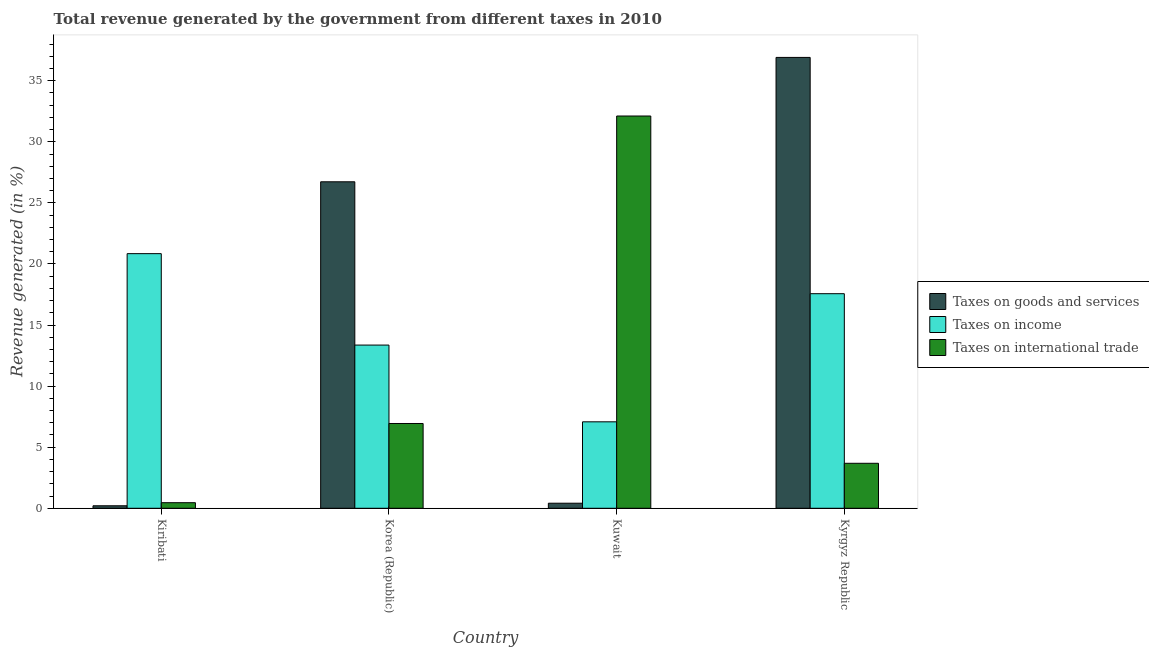Are the number of bars on each tick of the X-axis equal?
Keep it short and to the point. Yes. How many bars are there on the 3rd tick from the left?
Offer a terse response. 3. How many bars are there on the 1st tick from the right?
Make the answer very short. 3. What is the label of the 4th group of bars from the left?
Provide a succinct answer. Kyrgyz Republic. What is the percentage of revenue generated by taxes on goods and services in Korea (Republic)?
Keep it short and to the point. 26.73. Across all countries, what is the maximum percentage of revenue generated by taxes on income?
Give a very brief answer. 20.84. Across all countries, what is the minimum percentage of revenue generated by tax on international trade?
Keep it short and to the point. 0.46. In which country was the percentage of revenue generated by tax on international trade maximum?
Offer a very short reply. Kuwait. In which country was the percentage of revenue generated by taxes on income minimum?
Offer a terse response. Kuwait. What is the total percentage of revenue generated by taxes on income in the graph?
Make the answer very short. 58.85. What is the difference between the percentage of revenue generated by taxes on income in Kiribati and that in Kyrgyz Republic?
Offer a very short reply. 3.28. What is the difference between the percentage of revenue generated by tax on international trade in Kiribati and the percentage of revenue generated by taxes on goods and services in Korea (Republic)?
Provide a succinct answer. -26.27. What is the average percentage of revenue generated by taxes on goods and services per country?
Your response must be concise. 16.06. What is the difference between the percentage of revenue generated by tax on international trade and percentage of revenue generated by taxes on income in Kiribati?
Keep it short and to the point. -20.39. What is the ratio of the percentage of revenue generated by tax on international trade in Kiribati to that in Kuwait?
Your answer should be compact. 0.01. Is the percentage of revenue generated by taxes on income in Kiribati less than that in Kyrgyz Republic?
Offer a very short reply. No. Is the difference between the percentage of revenue generated by taxes on goods and services in Kiribati and Kyrgyz Republic greater than the difference between the percentage of revenue generated by taxes on income in Kiribati and Kyrgyz Republic?
Make the answer very short. No. What is the difference between the highest and the second highest percentage of revenue generated by taxes on income?
Give a very brief answer. 3.28. What is the difference between the highest and the lowest percentage of revenue generated by taxes on income?
Keep it short and to the point. 13.77. In how many countries, is the percentage of revenue generated by taxes on goods and services greater than the average percentage of revenue generated by taxes on goods and services taken over all countries?
Provide a short and direct response. 2. What does the 3rd bar from the left in Kyrgyz Republic represents?
Your response must be concise. Taxes on international trade. What does the 3rd bar from the right in Kiribati represents?
Your answer should be very brief. Taxes on goods and services. Does the graph contain grids?
Make the answer very short. No. Where does the legend appear in the graph?
Give a very brief answer. Center right. How many legend labels are there?
Offer a terse response. 3. How are the legend labels stacked?
Your response must be concise. Vertical. What is the title of the graph?
Provide a short and direct response. Total revenue generated by the government from different taxes in 2010. What is the label or title of the X-axis?
Your response must be concise. Country. What is the label or title of the Y-axis?
Offer a terse response. Revenue generated (in %). What is the Revenue generated (in %) in Taxes on goods and services in Kiribati?
Your answer should be compact. 0.2. What is the Revenue generated (in %) of Taxes on income in Kiribati?
Ensure brevity in your answer.  20.84. What is the Revenue generated (in %) in Taxes on international trade in Kiribati?
Provide a succinct answer. 0.46. What is the Revenue generated (in %) of Taxes on goods and services in Korea (Republic)?
Your response must be concise. 26.73. What is the Revenue generated (in %) in Taxes on income in Korea (Republic)?
Ensure brevity in your answer.  13.36. What is the Revenue generated (in %) in Taxes on international trade in Korea (Republic)?
Your answer should be compact. 6.94. What is the Revenue generated (in %) in Taxes on goods and services in Kuwait?
Ensure brevity in your answer.  0.41. What is the Revenue generated (in %) in Taxes on income in Kuwait?
Your answer should be very brief. 7.08. What is the Revenue generated (in %) of Taxes on international trade in Kuwait?
Your answer should be very brief. 32.11. What is the Revenue generated (in %) of Taxes on goods and services in Kyrgyz Republic?
Make the answer very short. 36.91. What is the Revenue generated (in %) of Taxes on income in Kyrgyz Republic?
Provide a short and direct response. 17.57. What is the Revenue generated (in %) in Taxes on international trade in Kyrgyz Republic?
Your response must be concise. 3.68. Across all countries, what is the maximum Revenue generated (in %) of Taxes on goods and services?
Offer a terse response. 36.91. Across all countries, what is the maximum Revenue generated (in %) of Taxes on income?
Your answer should be very brief. 20.84. Across all countries, what is the maximum Revenue generated (in %) of Taxes on international trade?
Make the answer very short. 32.11. Across all countries, what is the minimum Revenue generated (in %) of Taxes on goods and services?
Offer a terse response. 0.2. Across all countries, what is the minimum Revenue generated (in %) in Taxes on income?
Provide a succinct answer. 7.08. Across all countries, what is the minimum Revenue generated (in %) of Taxes on international trade?
Offer a terse response. 0.46. What is the total Revenue generated (in %) in Taxes on goods and services in the graph?
Provide a short and direct response. 64.25. What is the total Revenue generated (in %) of Taxes on income in the graph?
Keep it short and to the point. 58.85. What is the total Revenue generated (in %) of Taxes on international trade in the graph?
Your answer should be compact. 43.19. What is the difference between the Revenue generated (in %) of Taxes on goods and services in Kiribati and that in Korea (Republic)?
Your answer should be compact. -26.52. What is the difference between the Revenue generated (in %) in Taxes on income in Kiribati and that in Korea (Republic)?
Make the answer very short. 7.48. What is the difference between the Revenue generated (in %) of Taxes on international trade in Kiribati and that in Korea (Republic)?
Your response must be concise. -6.48. What is the difference between the Revenue generated (in %) of Taxes on goods and services in Kiribati and that in Kuwait?
Keep it short and to the point. -0.21. What is the difference between the Revenue generated (in %) in Taxes on income in Kiribati and that in Kuwait?
Offer a terse response. 13.77. What is the difference between the Revenue generated (in %) in Taxes on international trade in Kiribati and that in Kuwait?
Provide a short and direct response. -31.66. What is the difference between the Revenue generated (in %) of Taxes on goods and services in Kiribati and that in Kyrgyz Republic?
Ensure brevity in your answer.  -36.7. What is the difference between the Revenue generated (in %) in Taxes on income in Kiribati and that in Kyrgyz Republic?
Give a very brief answer. 3.28. What is the difference between the Revenue generated (in %) of Taxes on international trade in Kiribati and that in Kyrgyz Republic?
Ensure brevity in your answer.  -3.23. What is the difference between the Revenue generated (in %) of Taxes on goods and services in Korea (Republic) and that in Kuwait?
Your answer should be very brief. 26.31. What is the difference between the Revenue generated (in %) in Taxes on income in Korea (Republic) and that in Kuwait?
Ensure brevity in your answer.  6.28. What is the difference between the Revenue generated (in %) of Taxes on international trade in Korea (Republic) and that in Kuwait?
Make the answer very short. -25.17. What is the difference between the Revenue generated (in %) of Taxes on goods and services in Korea (Republic) and that in Kyrgyz Republic?
Provide a succinct answer. -10.18. What is the difference between the Revenue generated (in %) in Taxes on income in Korea (Republic) and that in Kyrgyz Republic?
Provide a succinct answer. -4.21. What is the difference between the Revenue generated (in %) in Taxes on international trade in Korea (Republic) and that in Kyrgyz Republic?
Your answer should be compact. 3.26. What is the difference between the Revenue generated (in %) in Taxes on goods and services in Kuwait and that in Kyrgyz Republic?
Ensure brevity in your answer.  -36.49. What is the difference between the Revenue generated (in %) of Taxes on income in Kuwait and that in Kyrgyz Republic?
Give a very brief answer. -10.49. What is the difference between the Revenue generated (in %) in Taxes on international trade in Kuwait and that in Kyrgyz Republic?
Offer a very short reply. 28.43. What is the difference between the Revenue generated (in %) in Taxes on goods and services in Kiribati and the Revenue generated (in %) in Taxes on income in Korea (Republic)?
Ensure brevity in your answer.  -13.16. What is the difference between the Revenue generated (in %) of Taxes on goods and services in Kiribati and the Revenue generated (in %) of Taxes on international trade in Korea (Republic)?
Your answer should be compact. -6.74. What is the difference between the Revenue generated (in %) in Taxes on income in Kiribati and the Revenue generated (in %) in Taxes on international trade in Korea (Republic)?
Your response must be concise. 13.91. What is the difference between the Revenue generated (in %) in Taxes on goods and services in Kiribati and the Revenue generated (in %) in Taxes on income in Kuwait?
Make the answer very short. -6.87. What is the difference between the Revenue generated (in %) in Taxes on goods and services in Kiribati and the Revenue generated (in %) in Taxes on international trade in Kuwait?
Your answer should be very brief. -31.91. What is the difference between the Revenue generated (in %) in Taxes on income in Kiribati and the Revenue generated (in %) in Taxes on international trade in Kuwait?
Your answer should be compact. -11.27. What is the difference between the Revenue generated (in %) in Taxes on goods and services in Kiribati and the Revenue generated (in %) in Taxes on income in Kyrgyz Republic?
Make the answer very short. -17.36. What is the difference between the Revenue generated (in %) in Taxes on goods and services in Kiribati and the Revenue generated (in %) in Taxes on international trade in Kyrgyz Republic?
Provide a succinct answer. -3.48. What is the difference between the Revenue generated (in %) in Taxes on income in Kiribati and the Revenue generated (in %) in Taxes on international trade in Kyrgyz Republic?
Offer a terse response. 17.16. What is the difference between the Revenue generated (in %) of Taxes on goods and services in Korea (Republic) and the Revenue generated (in %) of Taxes on income in Kuwait?
Ensure brevity in your answer.  19.65. What is the difference between the Revenue generated (in %) of Taxes on goods and services in Korea (Republic) and the Revenue generated (in %) of Taxes on international trade in Kuwait?
Your answer should be very brief. -5.39. What is the difference between the Revenue generated (in %) of Taxes on income in Korea (Republic) and the Revenue generated (in %) of Taxes on international trade in Kuwait?
Your answer should be compact. -18.75. What is the difference between the Revenue generated (in %) in Taxes on goods and services in Korea (Republic) and the Revenue generated (in %) in Taxes on income in Kyrgyz Republic?
Offer a very short reply. 9.16. What is the difference between the Revenue generated (in %) in Taxes on goods and services in Korea (Republic) and the Revenue generated (in %) in Taxes on international trade in Kyrgyz Republic?
Give a very brief answer. 23.04. What is the difference between the Revenue generated (in %) of Taxes on income in Korea (Republic) and the Revenue generated (in %) of Taxes on international trade in Kyrgyz Republic?
Keep it short and to the point. 9.68. What is the difference between the Revenue generated (in %) in Taxes on goods and services in Kuwait and the Revenue generated (in %) in Taxes on income in Kyrgyz Republic?
Your response must be concise. -17.15. What is the difference between the Revenue generated (in %) in Taxes on goods and services in Kuwait and the Revenue generated (in %) in Taxes on international trade in Kyrgyz Republic?
Offer a terse response. -3.27. What is the difference between the Revenue generated (in %) in Taxes on income in Kuwait and the Revenue generated (in %) in Taxes on international trade in Kyrgyz Republic?
Provide a succinct answer. 3.39. What is the average Revenue generated (in %) in Taxes on goods and services per country?
Make the answer very short. 16.06. What is the average Revenue generated (in %) of Taxes on income per country?
Offer a terse response. 14.71. What is the average Revenue generated (in %) in Taxes on international trade per country?
Make the answer very short. 10.8. What is the difference between the Revenue generated (in %) in Taxes on goods and services and Revenue generated (in %) in Taxes on income in Kiribati?
Your answer should be compact. -20.64. What is the difference between the Revenue generated (in %) of Taxes on goods and services and Revenue generated (in %) of Taxes on international trade in Kiribati?
Provide a succinct answer. -0.25. What is the difference between the Revenue generated (in %) of Taxes on income and Revenue generated (in %) of Taxes on international trade in Kiribati?
Offer a very short reply. 20.39. What is the difference between the Revenue generated (in %) of Taxes on goods and services and Revenue generated (in %) of Taxes on income in Korea (Republic)?
Give a very brief answer. 13.37. What is the difference between the Revenue generated (in %) in Taxes on goods and services and Revenue generated (in %) in Taxes on international trade in Korea (Republic)?
Provide a short and direct response. 19.79. What is the difference between the Revenue generated (in %) of Taxes on income and Revenue generated (in %) of Taxes on international trade in Korea (Republic)?
Make the answer very short. 6.42. What is the difference between the Revenue generated (in %) of Taxes on goods and services and Revenue generated (in %) of Taxes on income in Kuwait?
Ensure brevity in your answer.  -6.66. What is the difference between the Revenue generated (in %) in Taxes on goods and services and Revenue generated (in %) in Taxes on international trade in Kuwait?
Ensure brevity in your answer.  -31.7. What is the difference between the Revenue generated (in %) in Taxes on income and Revenue generated (in %) in Taxes on international trade in Kuwait?
Your answer should be very brief. -25.04. What is the difference between the Revenue generated (in %) in Taxes on goods and services and Revenue generated (in %) in Taxes on income in Kyrgyz Republic?
Offer a terse response. 19.34. What is the difference between the Revenue generated (in %) of Taxes on goods and services and Revenue generated (in %) of Taxes on international trade in Kyrgyz Republic?
Provide a succinct answer. 33.23. What is the difference between the Revenue generated (in %) of Taxes on income and Revenue generated (in %) of Taxes on international trade in Kyrgyz Republic?
Provide a succinct answer. 13.88. What is the ratio of the Revenue generated (in %) of Taxes on goods and services in Kiribati to that in Korea (Republic)?
Your answer should be very brief. 0.01. What is the ratio of the Revenue generated (in %) in Taxes on income in Kiribati to that in Korea (Republic)?
Offer a terse response. 1.56. What is the ratio of the Revenue generated (in %) of Taxes on international trade in Kiribati to that in Korea (Republic)?
Keep it short and to the point. 0.07. What is the ratio of the Revenue generated (in %) in Taxes on goods and services in Kiribati to that in Kuwait?
Offer a very short reply. 0.49. What is the ratio of the Revenue generated (in %) of Taxes on income in Kiribati to that in Kuwait?
Ensure brevity in your answer.  2.95. What is the ratio of the Revenue generated (in %) of Taxes on international trade in Kiribati to that in Kuwait?
Your answer should be very brief. 0.01. What is the ratio of the Revenue generated (in %) in Taxes on goods and services in Kiribati to that in Kyrgyz Republic?
Give a very brief answer. 0.01. What is the ratio of the Revenue generated (in %) in Taxes on income in Kiribati to that in Kyrgyz Republic?
Provide a short and direct response. 1.19. What is the ratio of the Revenue generated (in %) of Taxes on international trade in Kiribati to that in Kyrgyz Republic?
Your answer should be compact. 0.12. What is the ratio of the Revenue generated (in %) of Taxes on goods and services in Korea (Republic) to that in Kuwait?
Your response must be concise. 64.51. What is the ratio of the Revenue generated (in %) in Taxes on income in Korea (Republic) to that in Kuwait?
Ensure brevity in your answer.  1.89. What is the ratio of the Revenue generated (in %) of Taxes on international trade in Korea (Republic) to that in Kuwait?
Your answer should be very brief. 0.22. What is the ratio of the Revenue generated (in %) in Taxes on goods and services in Korea (Republic) to that in Kyrgyz Republic?
Provide a succinct answer. 0.72. What is the ratio of the Revenue generated (in %) in Taxes on income in Korea (Republic) to that in Kyrgyz Republic?
Give a very brief answer. 0.76. What is the ratio of the Revenue generated (in %) in Taxes on international trade in Korea (Republic) to that in Kyrgyz Republic?
Your answer should be compact. 1.88. What is the ratio of the Revenue generated (in %) in Taxes on goods and services in Kuwait to that in Kyrgyz Republic?
Your answer should be very brief. 0.01. What is the ratio of the Revenue generated (in %) of Taxes on income in Kuwait to that in Kyrgyz Republic?
Provide a succinct answer. 0.4. What is the ratio of the Revenue generated (in %) in Taxes on international trade in Kuwait to that in Kyrgyz Republic?
Ensure brevity in your answer.  8.72. What is the difference between the highest and the second highest Revenue generated (in %) in Taxes on goods and services?
Keep it short and to the point. 10.18. What is the difference between the highest and the second highest Revenue generated (in %) of Taxes on income?
Give a very brief answer. 3.28. What is the difference between the highest and the second highest Revenue generated (in %) of Taxes on international trade?
Your answer should be very brief. 25.17. What is the difference between the highest and the lowest Revenue generated (in %) in Taxes on goods and services?
Make the answer very short. 36.7. What is the difference between the highest and the lowest Revenue generated (in %) of Taxes on income?
Offer a very short reply. 13.77. What is the difference between the highest and the lowest Revenue generated (in %) in Taxes on international trade?
Provide a short and direct response. 31.66. 